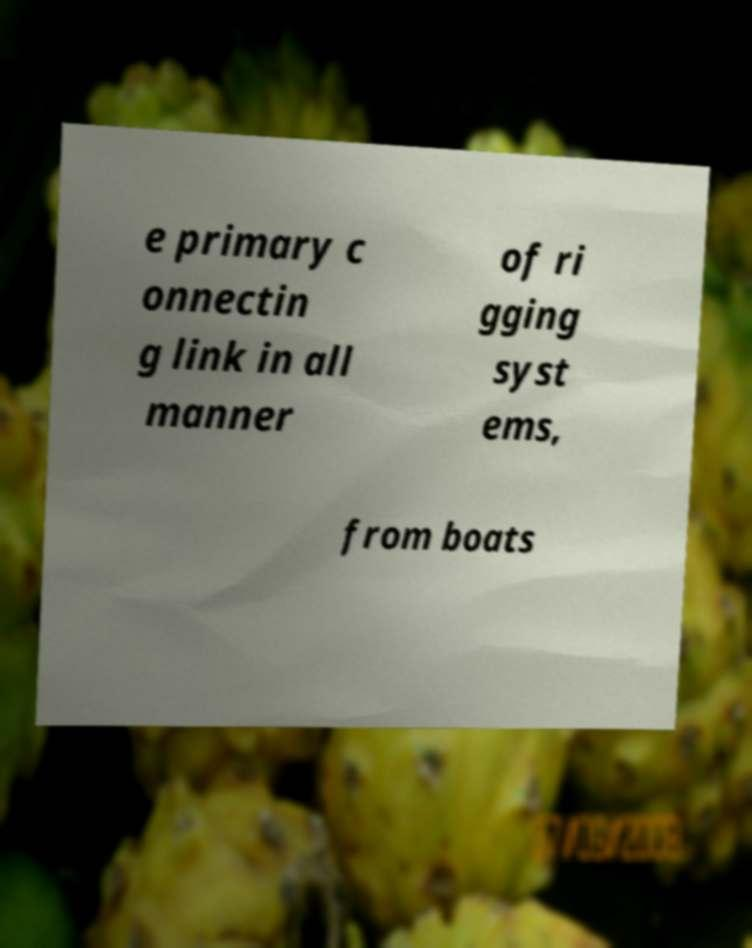Please read and relay the text visible in this image. What does it say? e primary c onnectin g link in all manner of ri gging syst ems, from boats 